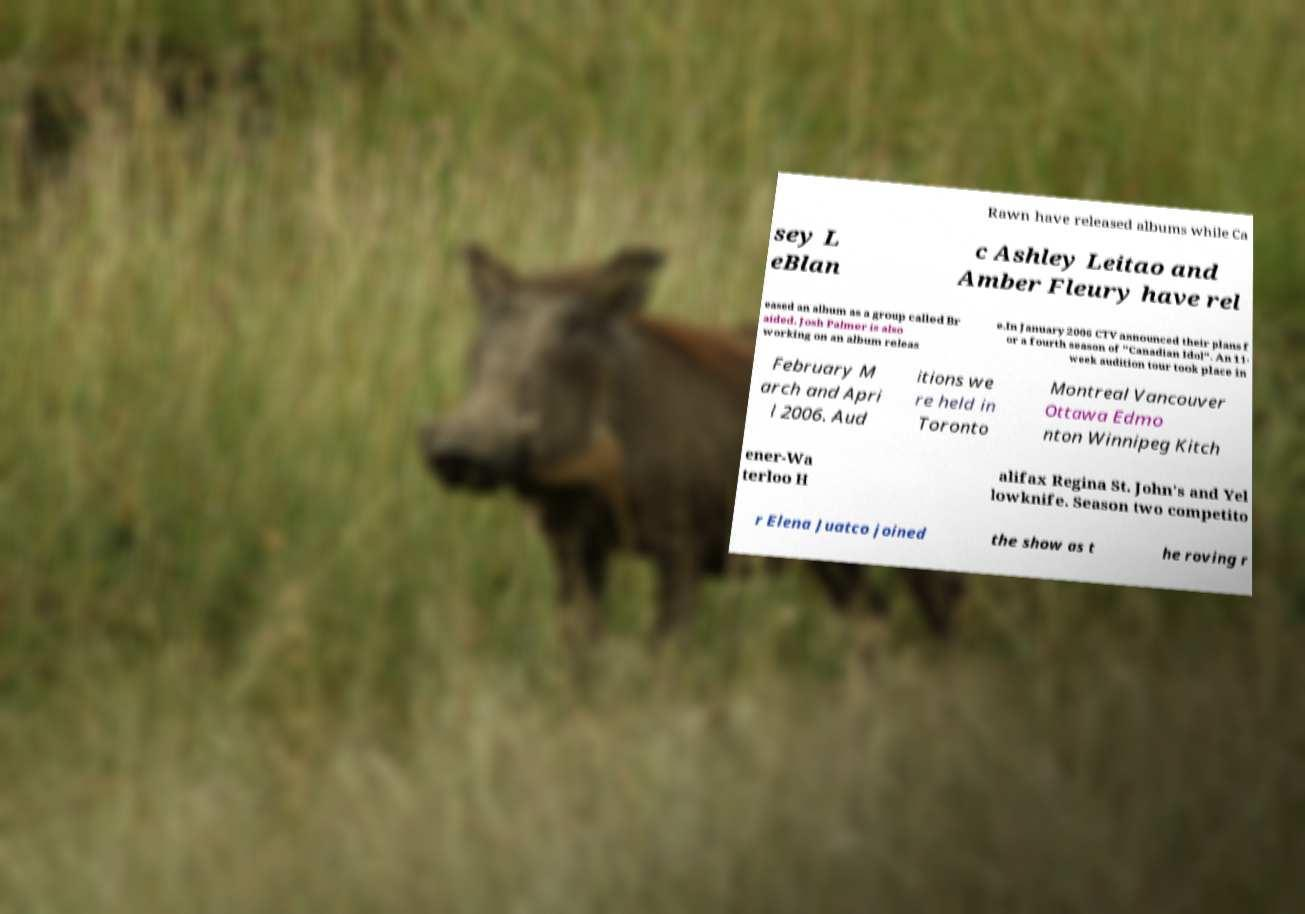For documentation purposes, I need the text within this image transcribed. Could you provide that? Rawn have released albums while Ca sey L eBlan c Ashley Leitao and Amber Fleury have rel eased an album as a group called Br aided. Josh Palmer is also working on an album releas e.In January 2006 CTV announced their plans f or a fourth season of "Canadian Idol". An 11- week audition tour took place in February M arch and Apri l 2006. Aud itions we re held in Toronto Montreal Vancouver Ottawa Edmo nton Winnipeg Kitch ener-Wa terloo H alifax Regina St. John's and Yel lowknife. Season two competito r Elena Juatco joined the show as t he roving r 